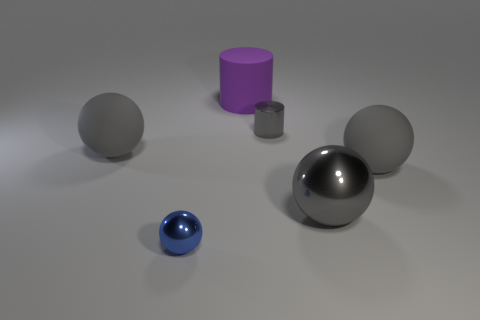Are there any other things that are the same color as the tiny cylinder?
Provide a succinct answer. Yes. What number of other objects are there of the same shape as the big purple object?
Offer a very short reply. 1. What color is the metal cylinder that is the same size as the blue object?
Give a very brief answer. Gray. Are there an equal number of small metal cylinders that are right of the big gray metallic sphere and big yellow blocks?
Provide a short and direct response. Yes. The large object that is both in front of the big purple cylinder and on the left side of the tiny cylinder has what shape?
Provide a short and direct response. Sphere. Do the matte cylinder and the gray metallic sphere have the same size?
Your answer should be very brief. Yes. Is there a big object that has the same material as the small blue sphere?
Ensure brevity in your answer.  Yes. There is a metallic sphere that is the same color as the small cylinder; what is its size?
Provide a succinct answer. Large. What number of objects are both behind the tiny metallic cylinder and in front of the big gray metallic thing?
Your answer should be very brief. 0. There is a gray thing that is to the left of the large purple rubber thing; what is it made of?
Offer a very short reply. Rubber. 